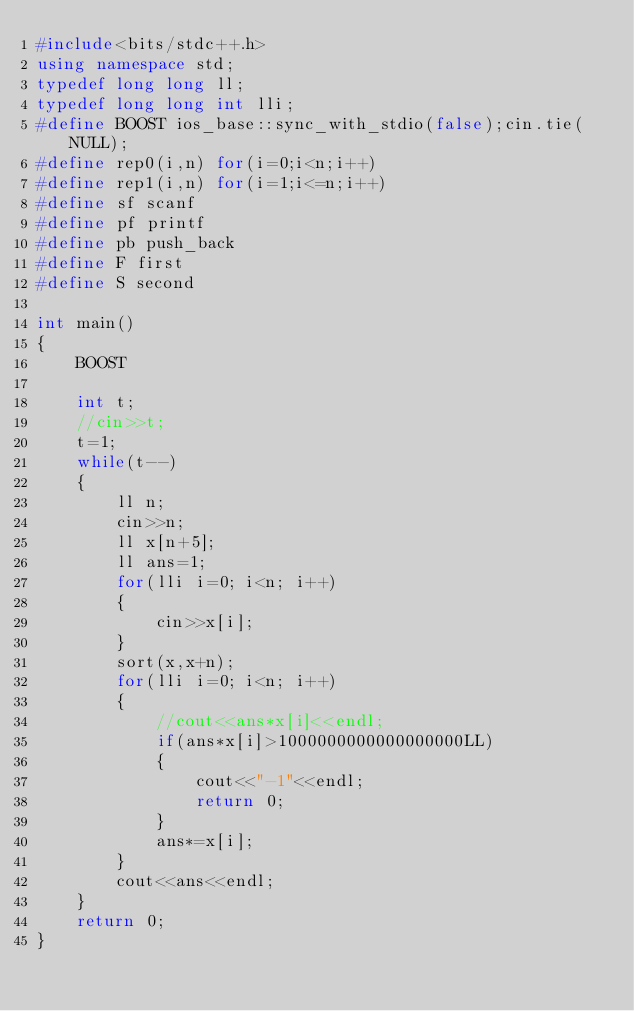Convert code to text. <code><loc_0><loc_0><loc_500><loc_500><_C++_>#include<bits/stdc++.h>
using namespace std;
typedef long long ll;
typedef long long int lli;
#define BOOST ios_base::sync_with_stdio(false);cin.tie(NULL);
#define rep0(i,n) for(i=0;i<n;i++)
#define rep1(i,n) for(i=1;i<=n;i++)
#define sf scanf
#define pf printf
#define pb push_back
#define F first
#define S second

int main()
{
    BOOST

    int t;
    //cin>>t;
    t=1;
    while(t--)
    {
        ll n;
        cin>>n;
        ll x[n+5];
        ll ans=1;
        for(lli i=0; i<n; i++)
        {
            cin>>x[i];
        }
        sort(x,x+n);
        for(lli i=0; i<n; i++)
        {
            //cout<<ans*x[i]<<endl;
            if(ans*x[i]>1000000000000000000LL)
            {
                cout<<"-1"<<endl;
                return 0;
            }
            ans*=x[i];
        }
        cout<<ans<<endl;
    }
    return 0;
}
</code> 